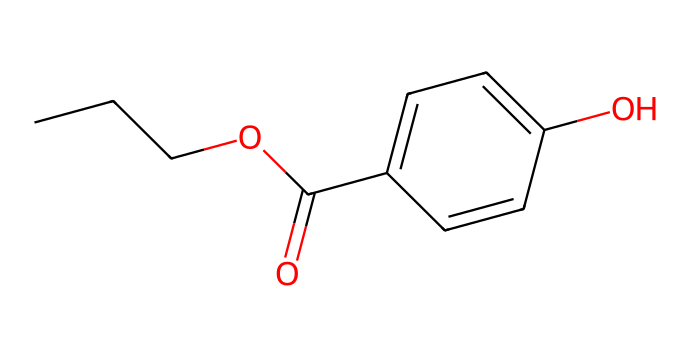What is the total number of carbon atoms in propylparaben? By analyzing the SMILES representation, we observe "CCCOC" which indicates a three-carbon chain (CCC) connected to an oxygen (O) and a carbonyl group (C=O), followed by a benzene ring structure "C1=CC=C(C=C1)". Each 'C' in the structure represents a carbon atom, resulting in a total of 10.
Answer: 10 How many oxygen atoms are present in propylparaben? In the SMILES notation "CCCOC(=O)", there are two oxygen atoms: one linked to the carbon chain and one in the carbonyl group (C=O). Therefore, counting both is essential.
Answer: 2 What is the functional group present in propylparaben? The SMILES structure indicates the presence of an ester functional group (RCOOR') due to the "OC(=O)" part at the beginning. The carbonyl and ether link together confirm it's an ester.
Answer: ester Is propylparaben a saturated or unsaturated compound? Propylparaben contains a benzene ring with alternating double bonds (indicated by C=C) which suggests that it is not entirely saturated. Therefore, the compound contains both saturated (straight-chain) and unsaturated (aromatic ring) portions, leading to the conclusion that it is unsaturated.
Answer: unsaturated What type of solvent would you expect propylparaben to be soluble in? Given the presence of both hydrophobic (benzene ring) and hydrophilic (ester group) components in its structure, propylparaben is likely to be soluble in organic solvents like alcohol or chloroform more so than water.
Answer: organic solvents 